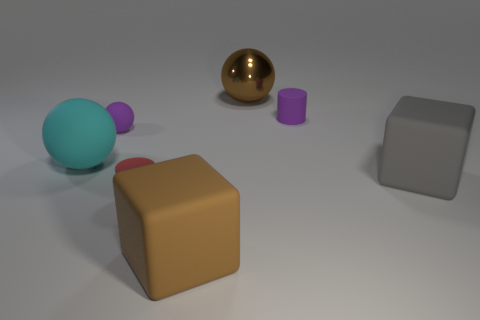Subtract all rubber spheres. How many spheres are left? 1 Add 2 large cubes. How many objects exist? 9 Subtract all purple balls. How many balls are left? 2 Subtract 2 balls. How many balls are left? 1 Subtract all blue blocks. Subtract all brown cylinders. How many blocks are left? 2 Add 7 red rubber things. How many red rubber things are left? 8 Add 2 brown objects. How many brown objects exist? 4 Subtract 0 blue spheres. How many objects are left? 7 Subtract all cylinders. How many objects are left? 5 Subtract all small brown matte cylinders. Subtract all large cyan rubber balls. How many objects are left? 6 